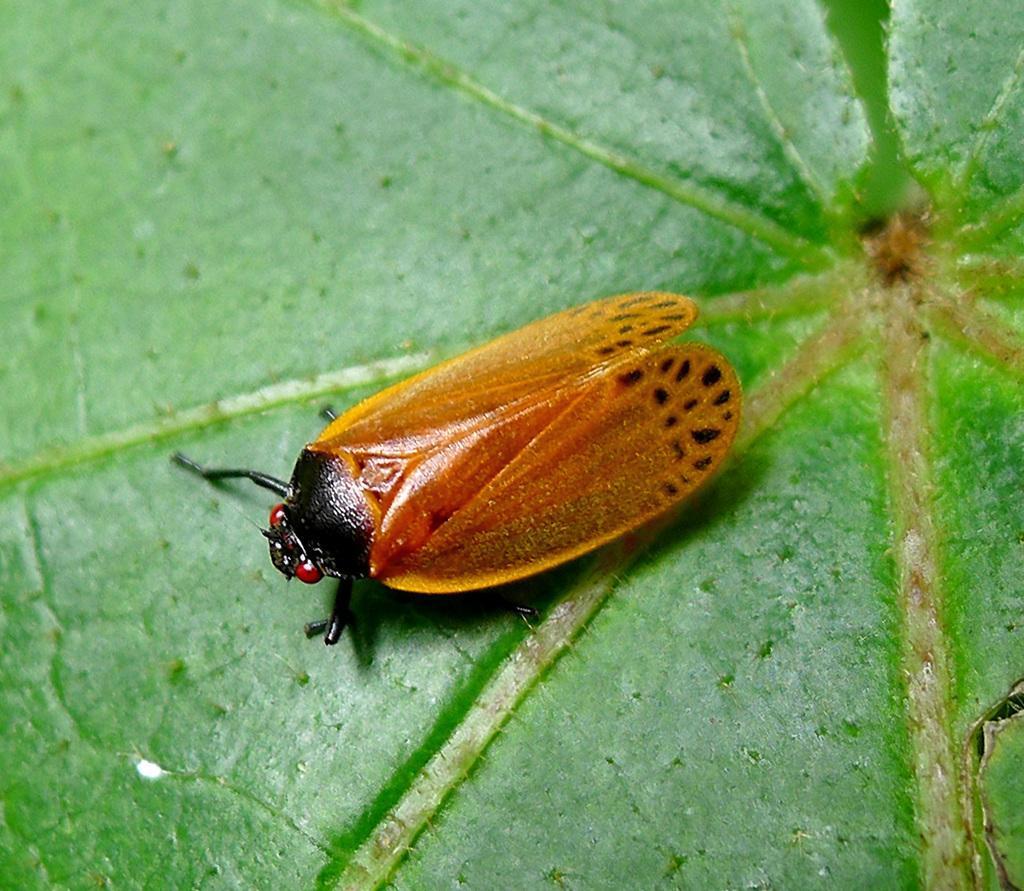Please provide a concise description of this image. In this picture there is a inset or fly which is standing on the leaf. 